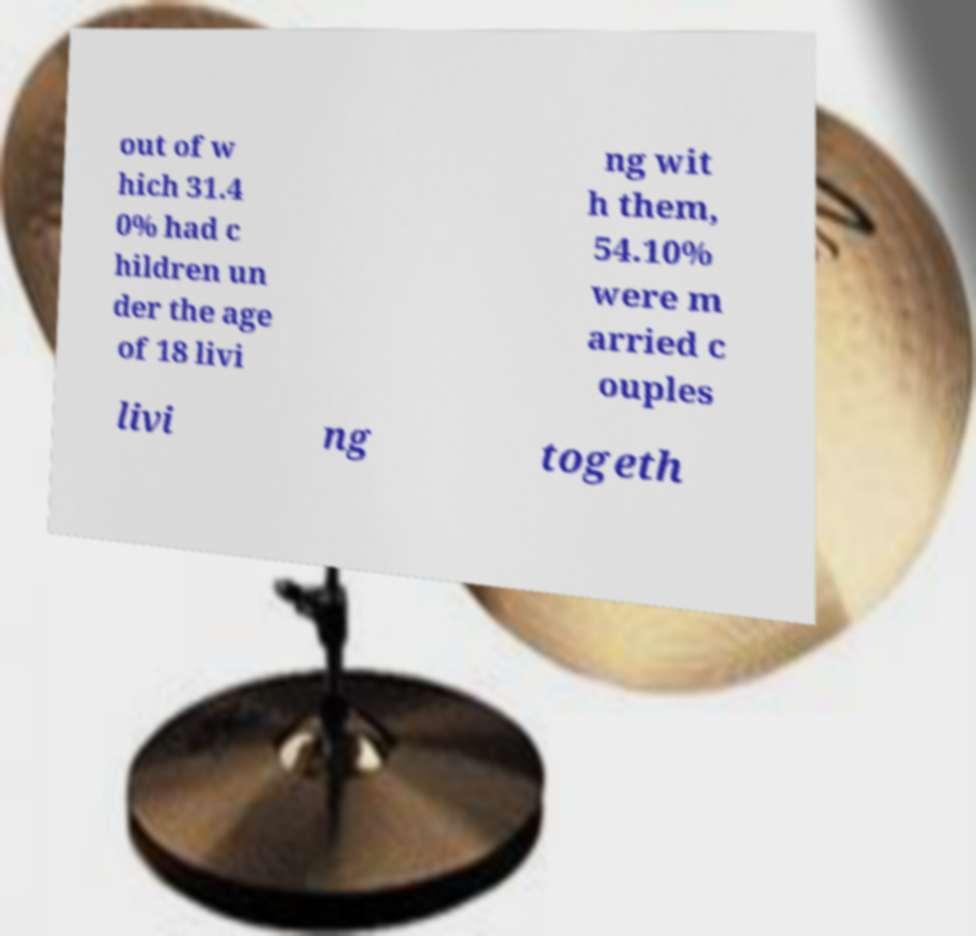There's text embedded in this image that I need extracted. Can you transcribe it verbatim? out of w hich 31.4 0% had c hildren un der the age of 18 livi ng wit h them, 54.10% were m arried c ouples livi ng togeth 